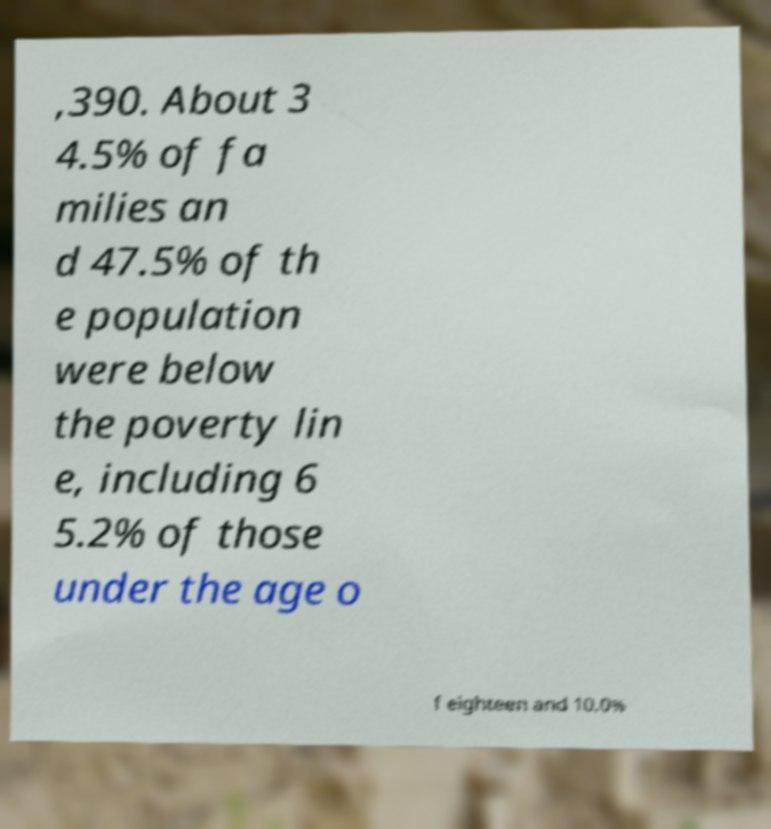For documentation purposes, I need the text within this image transcribed. Could you provide that? ,390. About 3 4.5% of fa milies an d 47.5% of th e population were below the poverty lin e, including 6 5.2% of those under the age o f eighteen and 10.0% 